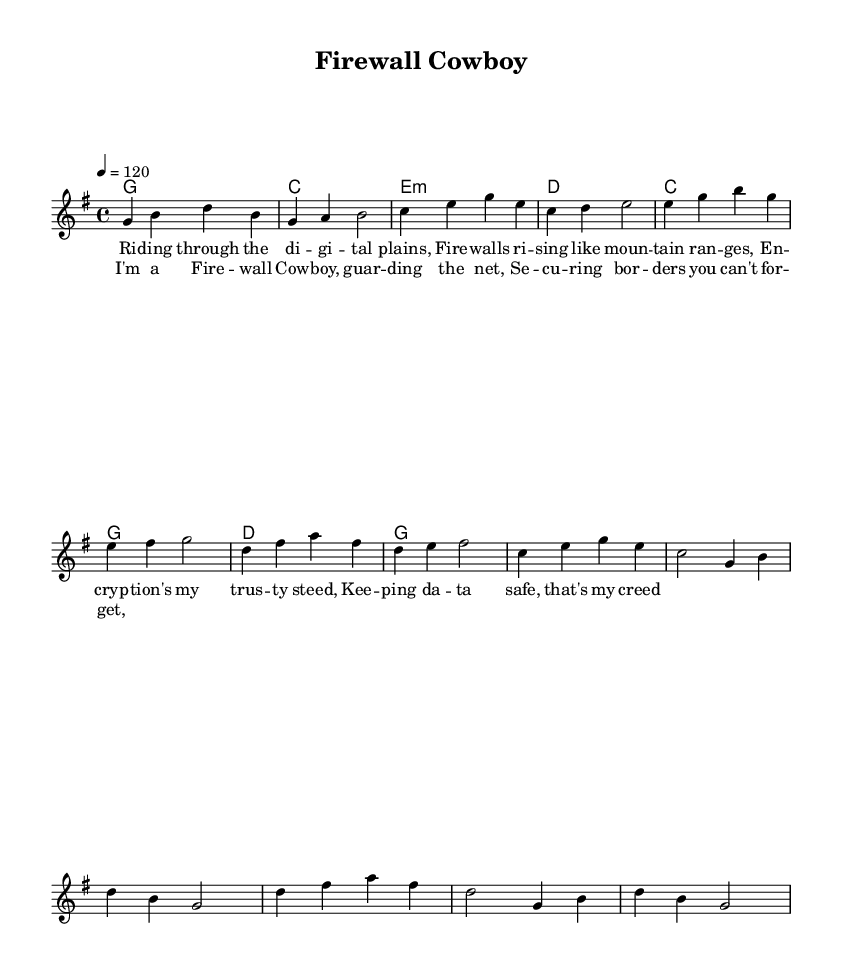What is the key signature of this music? The key signature is G major, which has one sharp (F#).
Answer: G major What is the time signature of this music? The time signature is 4/4, which means there are four beats in a measure with a quarter note getting one beat.
Answer: 4/4 What is the tempo marking in the music? The tempo marking is 120 beats per minute, indicating the speed of the piece.
Answer: 120 How many measures are in the verse? The verse consists of 8 measures, as counted in the melody section.
Answer: 8 What is the name of this song? The title of the song is "Firewall Cowboy," as stated in the header.
Answer: Firewall Cowboy What musical form is primarily used in this piece? The music uses a verse-chorus structure, alternating between verses and choruses.
Answer: Verse-Chorus What does the phrase "keeping data safe" symbolize in the context of country rock? This phrase symbolizes the fusion of technology and traditional country themes, addressing modern issues in a storytelling manner.
Answer: Protection 